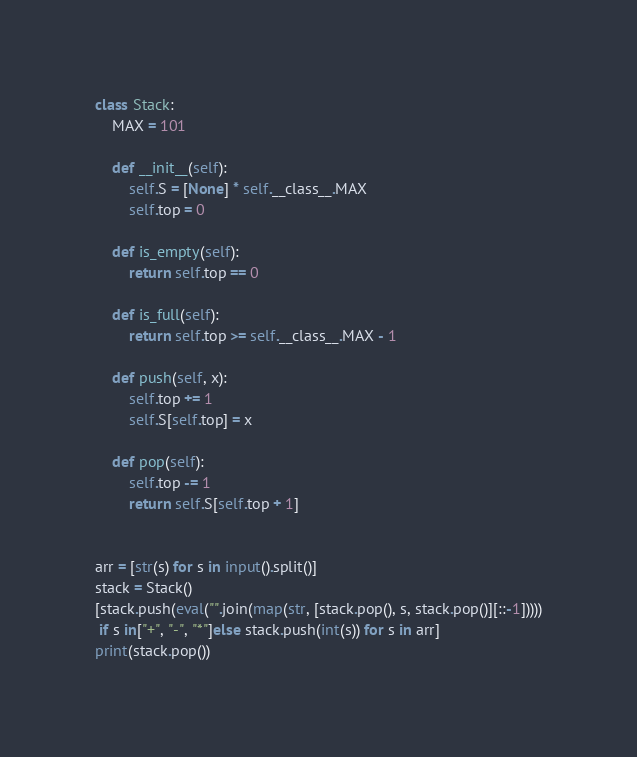Convert code to text. <code><loc_0><loc_0><loc_500><loc_500><_Python_>class Stack:
    MAX = 101

    def __init__(self):
        self.S = [None] * self.__class__.MAX
        self.top = 0

    def is_empty(self):
        return self.top == 0

    def is_full(self):
        return self.top >= self.__class__.MAX - 1

    def push(self, x):
        self.top += 1
        self.S[self.top] = x

    def pop(self):
        self.top -= 1
        return self.S[self.top + 1]


arr = [str(s) for s in input().split()]
stack = Stack()
[stack.push(eval("".join(map(str, [stack.pop(), s, stack.pop()][::-1]))))
 if s in["+", "-", "*"]else stack.push(int(s)) for s in arr]
print(stack.pop())

</code> 